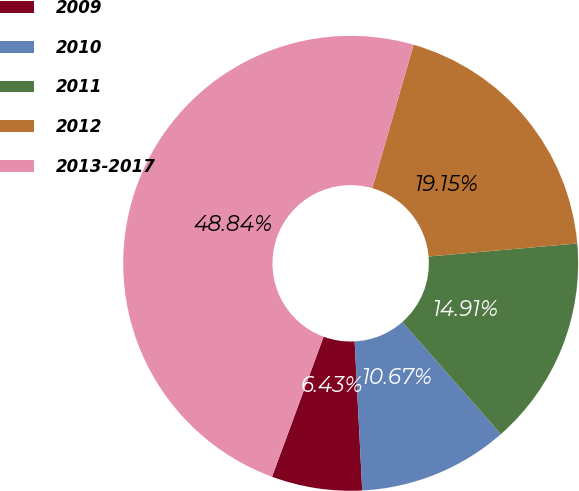Convert chart to OTSL. <chart><loc_0><loc_0><loc_500><loc_500><pie_chart><fcel>2009<fcel>2010<fcel>2011<fcel>2012<fcel>2013-2017<nl><fcel>6.43%<fcel>10.67%<fcel>14.91%<fcel>19.15%<fcel>48.84%<nl></chart> 